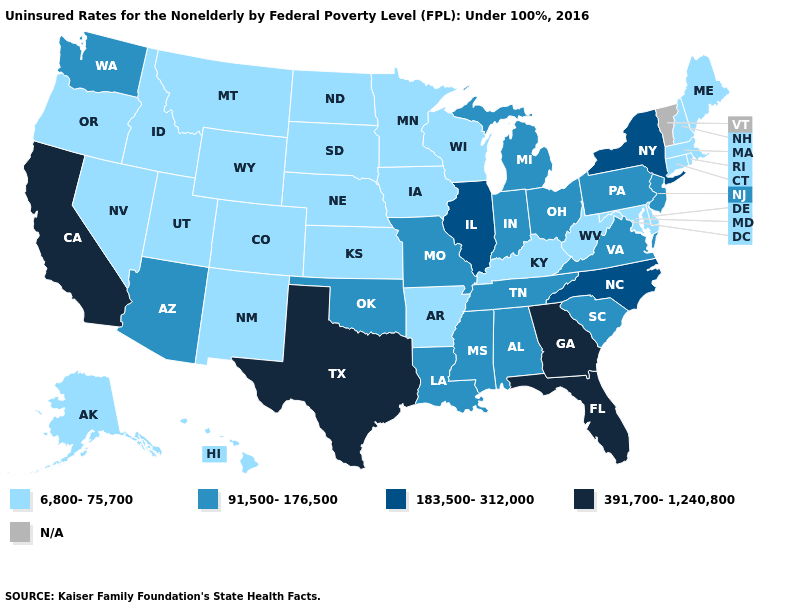What is the value of Oklahoma?
Answer briefly. 91,500-176,500. Does Ohio have the lowest value in the MidWest?
Be succinct. No. Name the states that have a value in the range N/A?
Give a very brief answer. Vermont. Name the states that have a value in the range N/A?
Be succinct. Vermont. What is the highest value in states that border Kentucky?
Short answer required. 183,500-312,000. What is the value of Michigan?
Be succinct. 91,500-176,500. Name the states that have a value in the range 183,500-312,000?
Be succinct. Illinois, New York, North Carolina. Name the states that have a value in the range 183,500-312,000?
Concise answer only. Illinois, New York, North Carolina. Which states have the lowest value in the South?
Short answer required. Arkansas, Delaware, Kentucky, Maryland, West Virginia. Which states have the lowest value in the USA?
Concise answer only. Alaska, Arkansas, Colorado, Connecticut, Delaware, Hawaii, Idaho, Iowa, Kansas, Kentucky, Maine, Maryland, Massachusetts, Minnesota, Montana, Nebraska, Nevada, New Hampshire, New Mexico, North Dakota, Oregon, Rhode Island, South Dakota, Utah, West Virginia, Wisconsin, Wyoming. Does New Jersey have the highest value in the Northeast?
Answer briefly. No. What is the lowest value in the South?
Write a very short answer. 6,800-75,700. Among the states that border Oklahoma , does Texas have the highest value?
Write a very short answer. Yes. What is the value of Wisconsin?
Concise answer only. 6,800-75,700. 